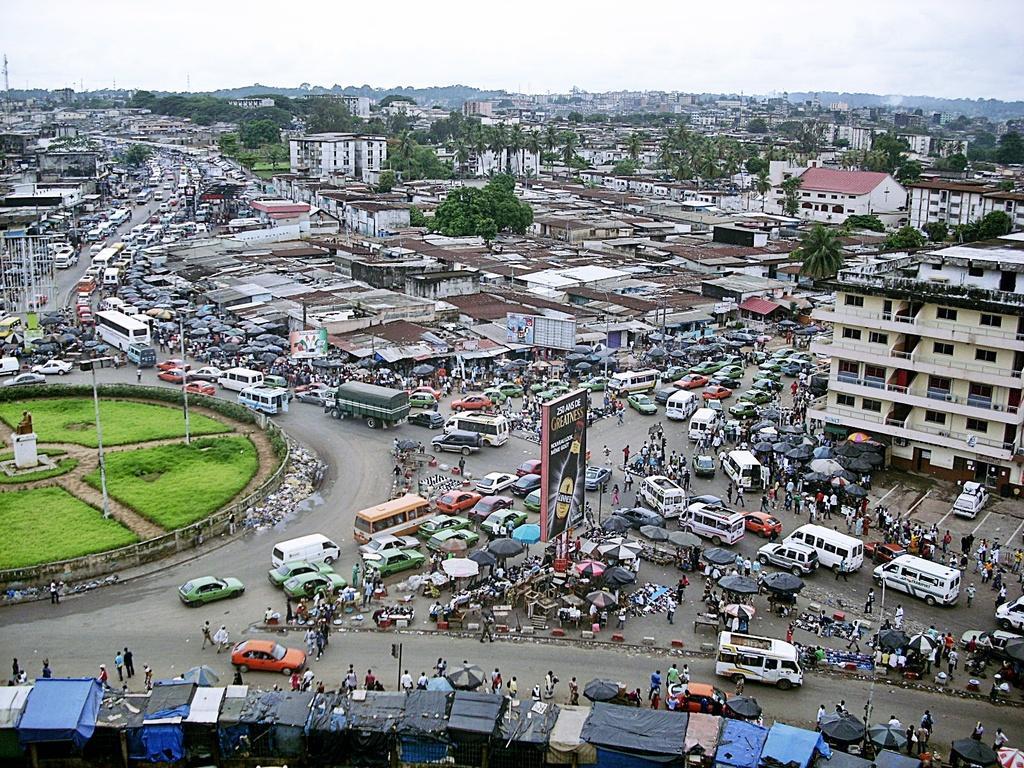Describe this image in one or two sentences. In this image I can see the road, number of vehicles on the road, some grass on the ground, few boards, few persons and few buildings. In the background I can see the sky. 